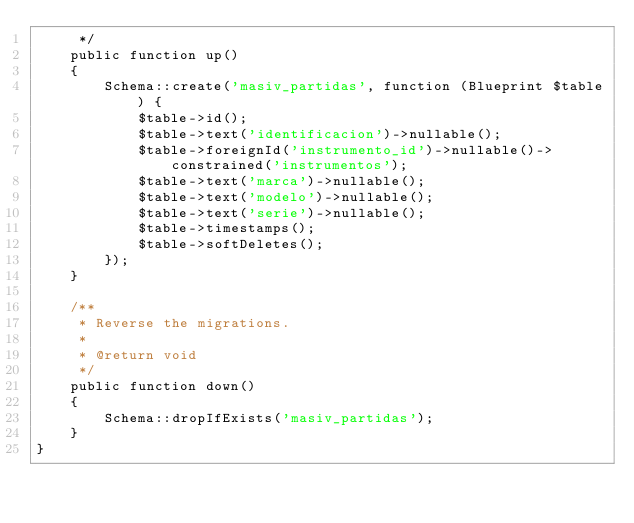Convert code to text. <code><loc_0><loc_0><loc_500><loc_500><_PHP_>     */
    public function up()
    {
        Schema::create('masiv_partidas', function (Blueprint $table) {
            $table->id();
            $table->text('identificacion')->nullable();
            $table->foreignId('instrumento_id')->nullable()->constrained('instrumentos');
            $table->text('marca')->nullable();
            $table->text('modelo')->nullable();
            $table->text('serie')->nullable();
            $table->timestamps();
            $table->softDeletes();
        });
    }

    /**
     * Reverse the migrations.
     *
     * @return void
     */
    public function down()
    {
        Schema::dropIfExists('masiv_partidas');
    }
}
</code> 